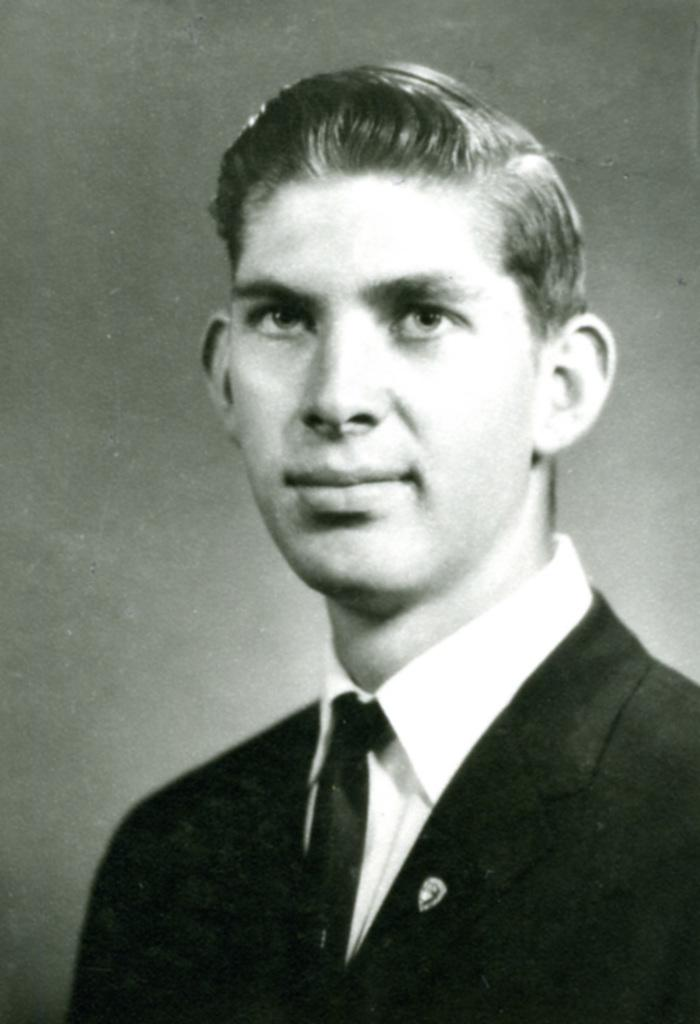Who is present in the image? There is a man in the image. What is the man wearing in the image? The man is wearing a coat and a tie. What is the color scheme of the image? The image is black and white. What is the man's facial expression in the image? The man is smiling in the image. What type of cork can be seen in the man's hand in the image? There is no cork present in the man's hand or in the image. How many passengers are visible in the image? There is only one person visible in the image, so there are no passengers. 